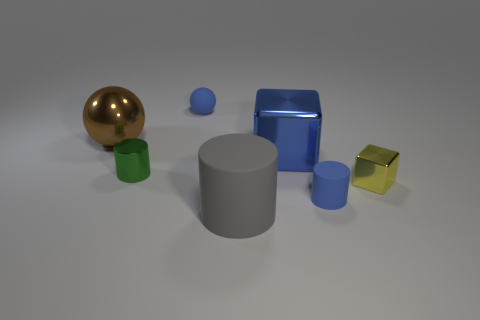Add 3 red rubber balls. How many objects exist? 10 Subtract all gray matte cylinders. How many cylinders are left? 2 Subtract all blocks. How many objects are left? 5 Add 2 tiny blue matte things. How many tiny blue matte things are left? 4 Add 7 large things. How many large things exist? 10 Subtract all yellow blocks. How many blocks are left? 1 Subtract 0 gray spheres. How many objects are left? 7 Subtract 1 balls. How many balls are left? 1 Subtract all yellow spheres. Subtract all purple blocks. How many spheres are left? 2 Subtract all brown cubes. How many blue spheres are left? 1 